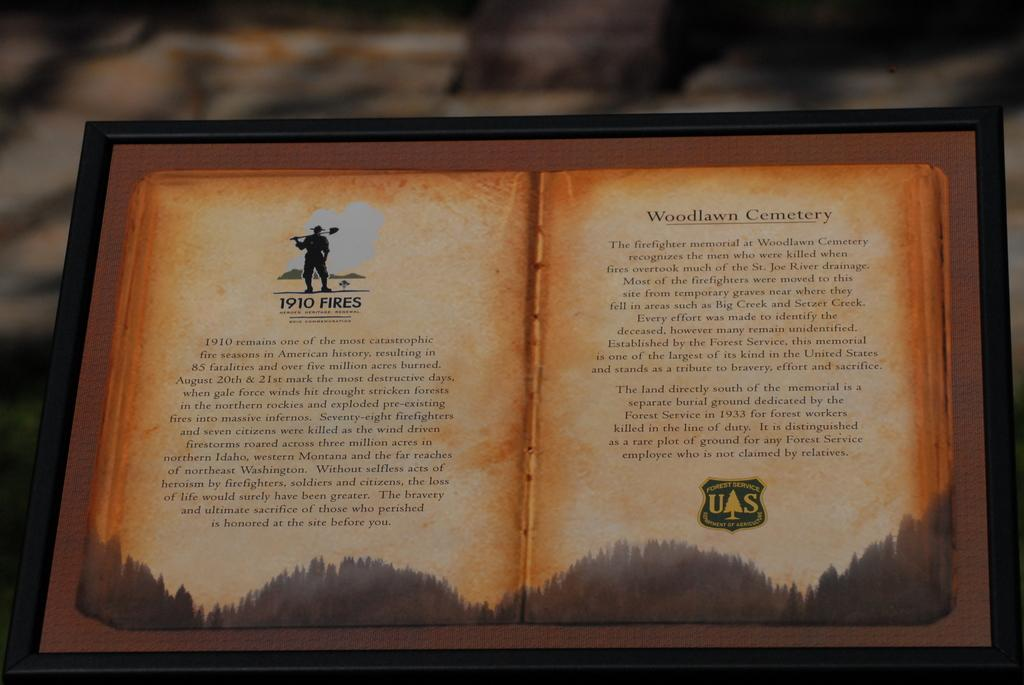<image>
Provide a brief description of the given image. The commemoration states that 1910 was one of the most catastrophic fire seasons in American history. 